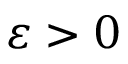Convert formula to latex. <formula><loc_0><loc_0><loc_500><loc_500>\varepsilon > 0</formula> 